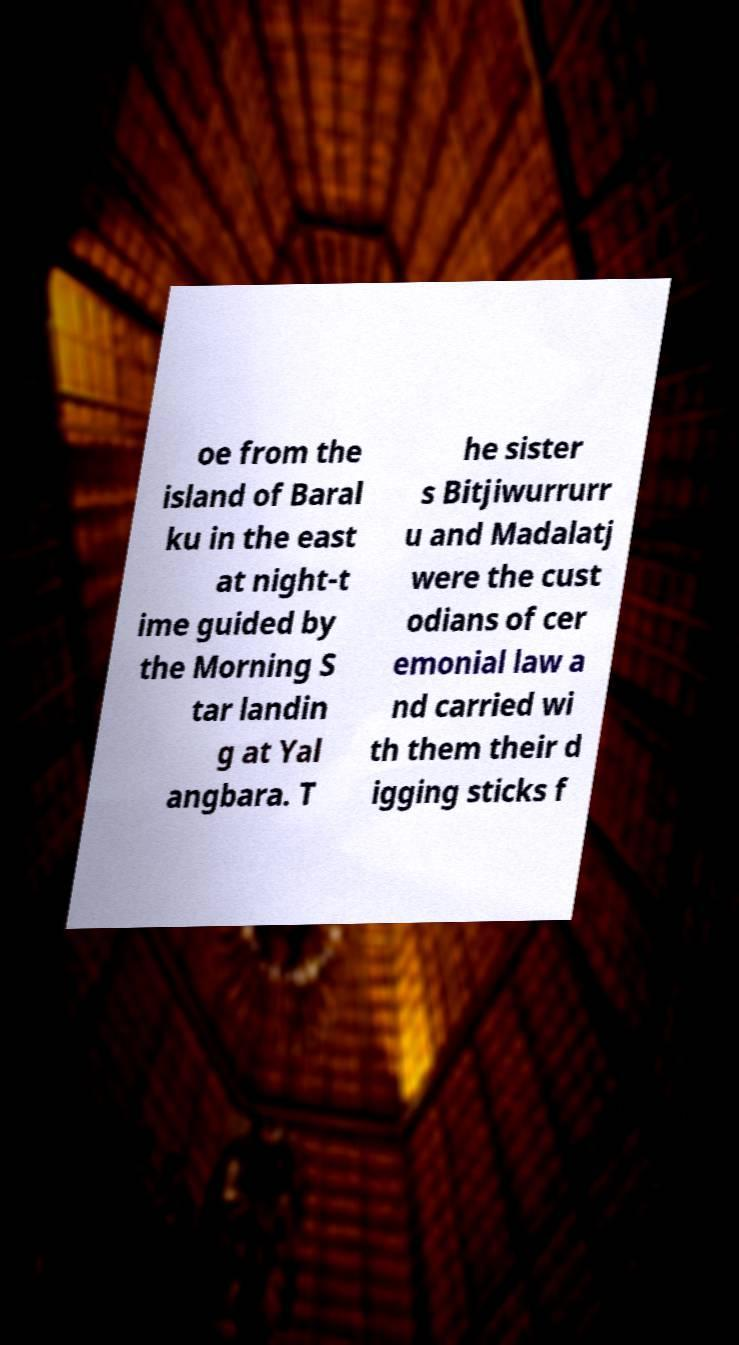Could you assist in decoding the text presented in this image and type it out clearly? oe from the island of Baral ku in the east at night-t ime guided by the Morning S tar landin g at Yal angbara. T he sister s Bitjiwurrurr u and Madalatj were the cust odians of cer emonial law a nd carried wi th them their d igging sticks f 